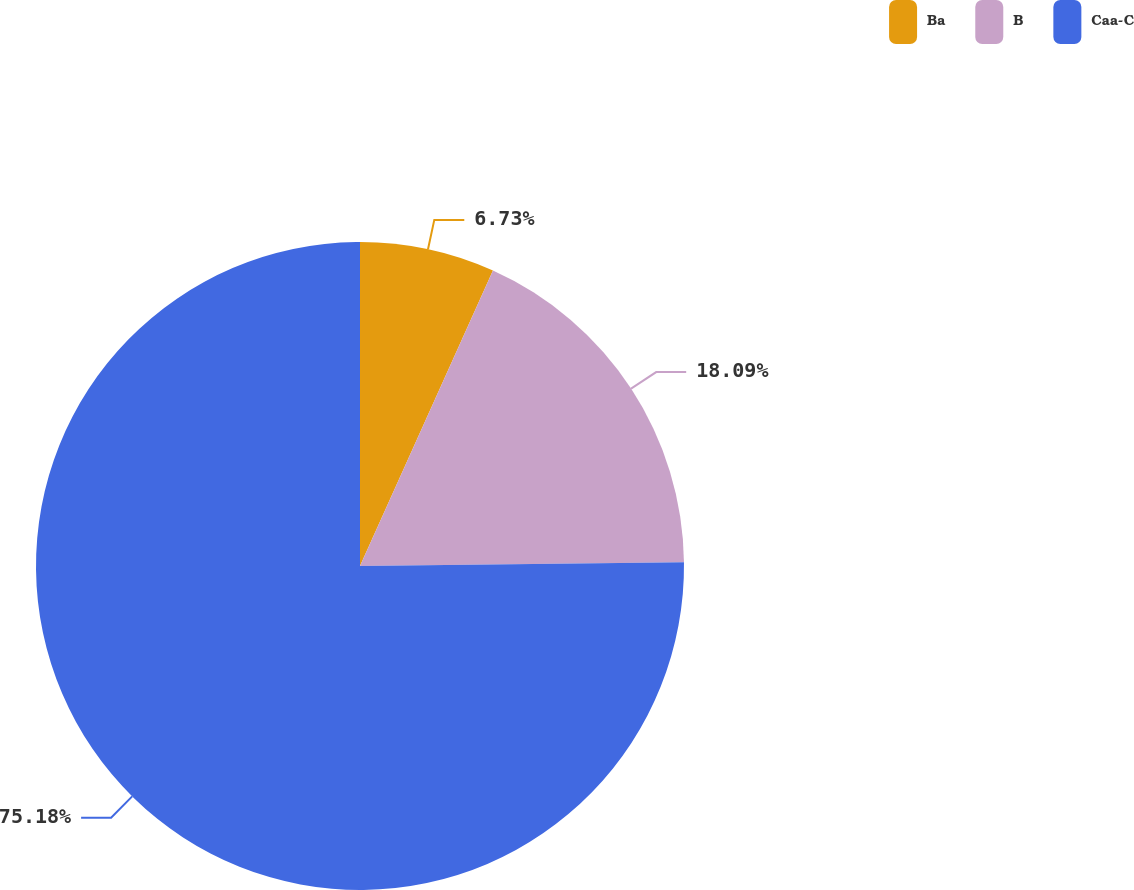<chart> <loc_0><loc_0><loc_500><loc_500><pie_chart><fcel>Ba<fcel>B<fcel>Caa-C<nl><fcel>6.73%<fcel>18.09%<fcel>75.18%<nl></chart> 